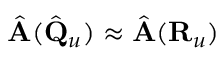<formula> <loc_0><loc_0><loc_500><loc_500>\hat { A } ( \hat { Q } _ { u } ) \approx \hat { A } ( { R } _ { u } )</formula> 